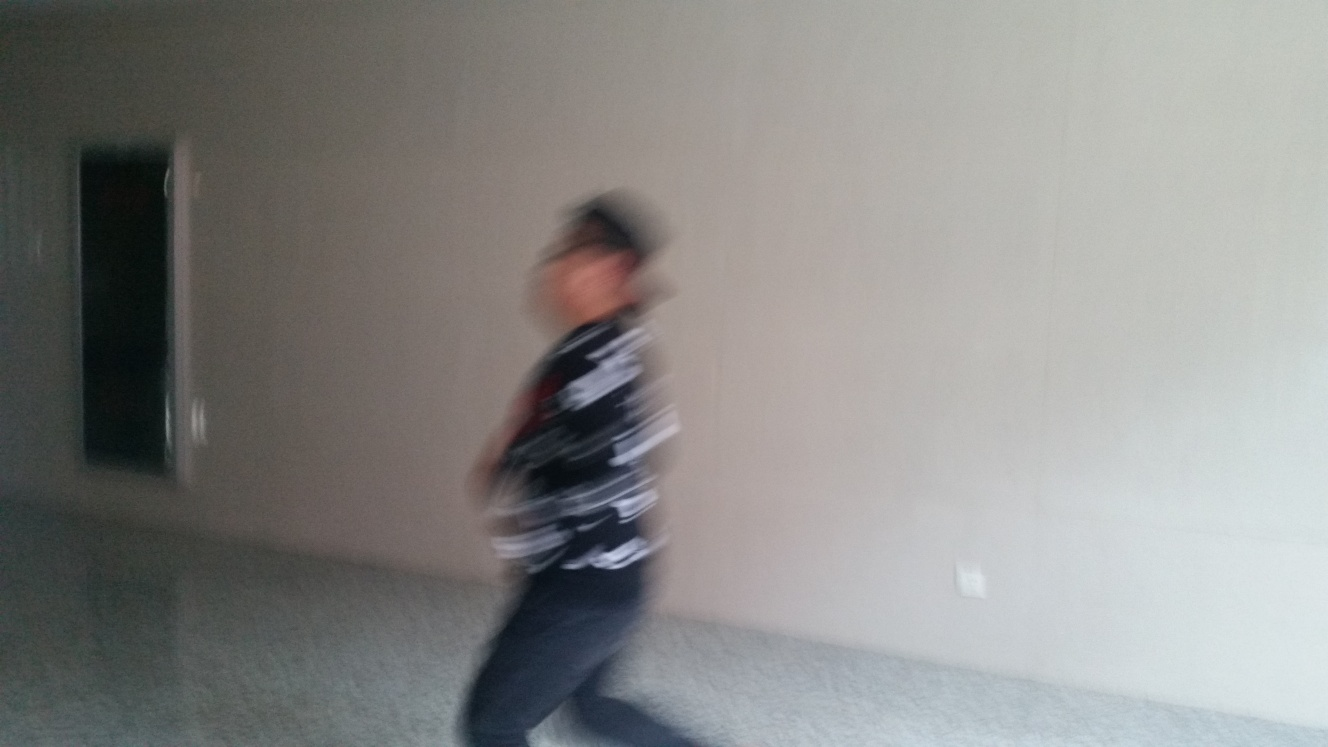Can you tell me more about the quality of the image? Certainly. The image is lacking in clarity and sharpness, likely due to a combination of low lighting, quick movement of the subject, and potentially a slow camera shutter speed. Additionally, there is a lack of depth in the colors, which may have been affected by the lighting conditions. What can be done to improve such a photo? To improve a photo like this, using a faster shutter speed could help freeze the action, reducing motion blur. Better lighting, either natural or artificial, would enhance the sharpness and color depth. Additionally, ensuring the camera is focused on the subject is crucial for a clear image. 